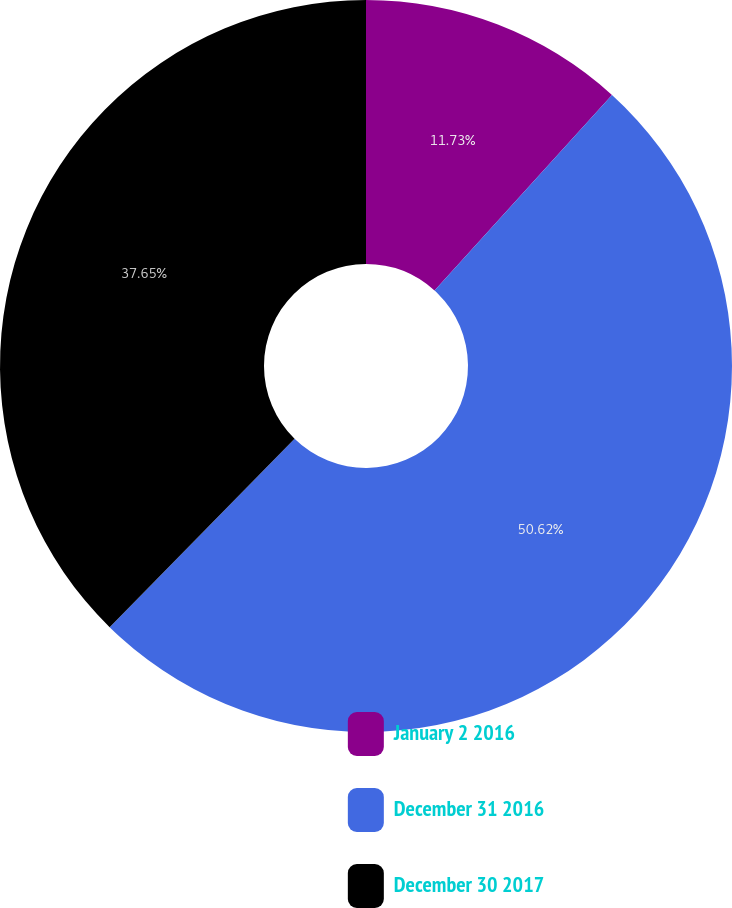Convert chart to OTSL. <chart><loc_0><loc_0><loc_500><loc_500><pie_chart><fcel>January 2 2016<fcel>December 31 2016<fcel>December 30 2017<nl><fcel>11.73%<fcel>50.62%<fcel>37.65%<nl></chart> 